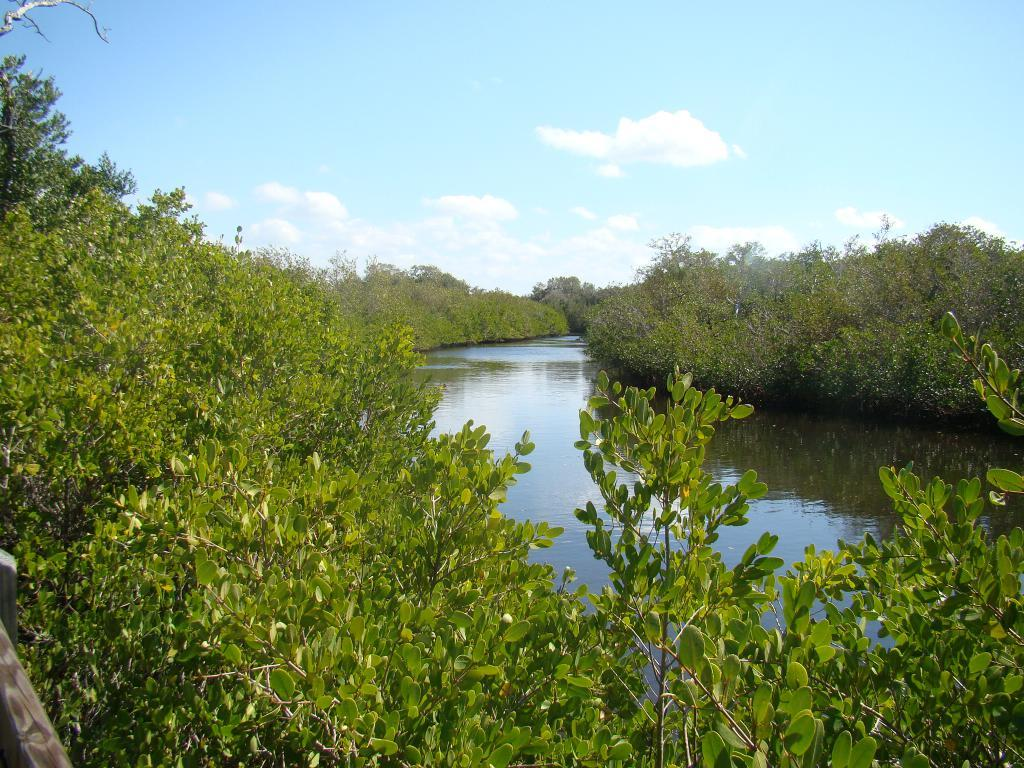What is the primary element visible in the image? There is water in the image. What type of vegetation can be seen in the image? There are trees in the image. What is visible in the background of the image? The sky is visible in the background of the image. What can be observed in the sky? Clouds are present in the sky. What time does the clock show in the image? There is no clock present in the image. Can you describe the behavior of the crow in the image? There is no crow present in the image. 